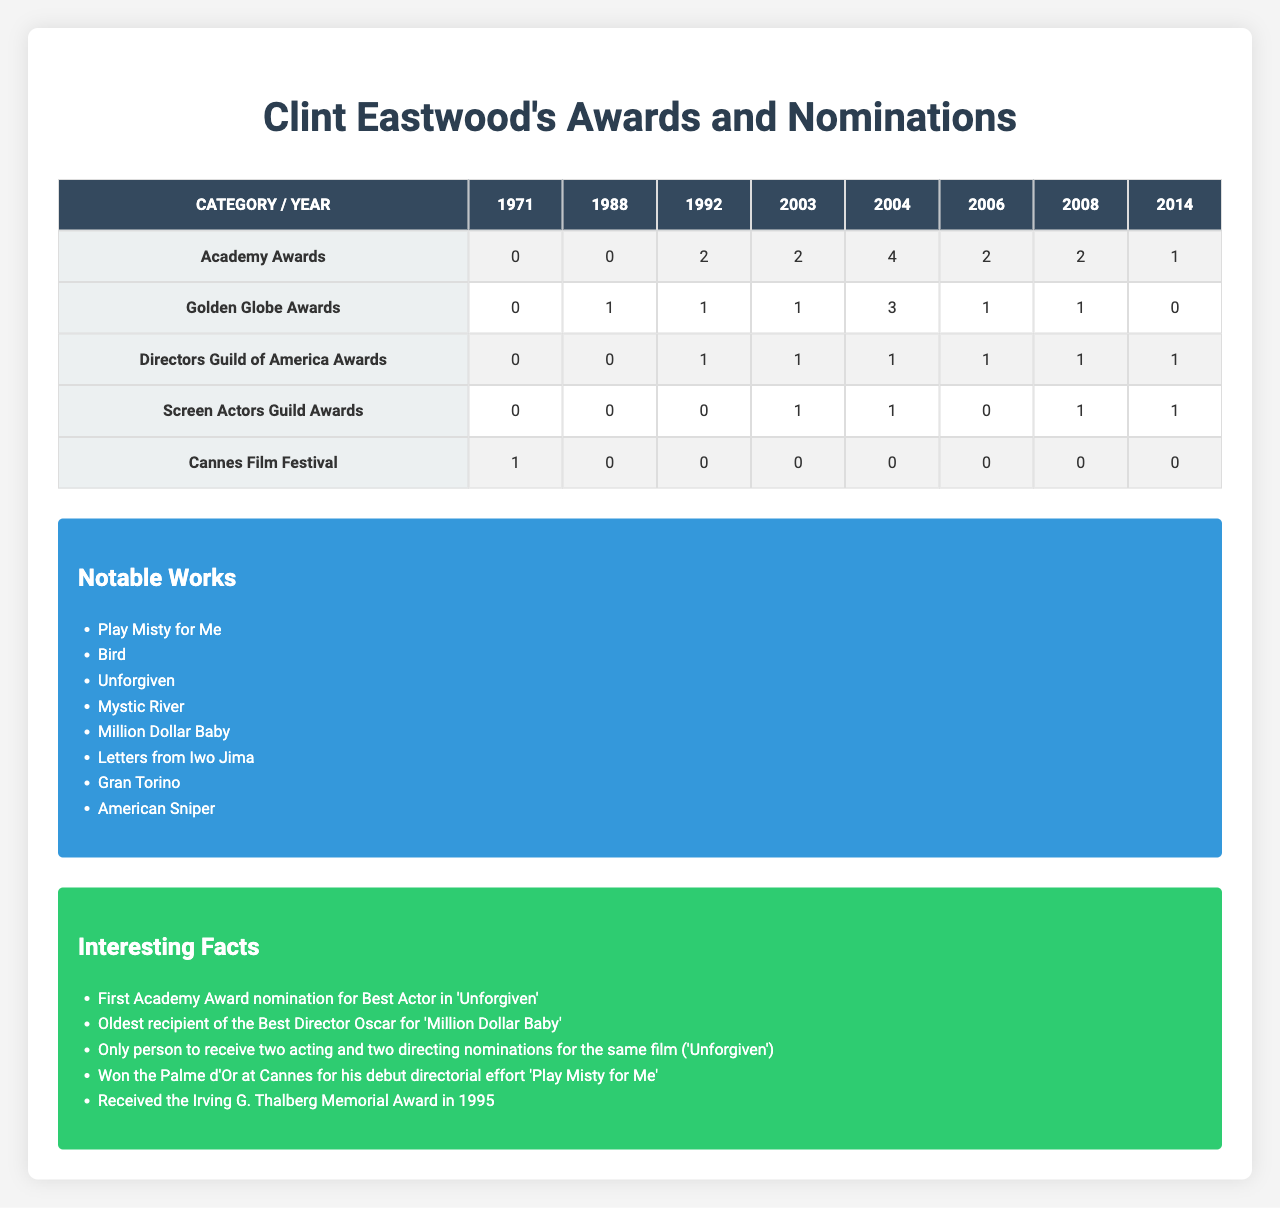What is the total number of Academy Awards won by Clint Eastwood? According to the table, Clint Eastwood won 2 Academy Awards in 2003 and 4 in 2004. The total number is 2 + 4 = 6.
Answer: 6 In which year did Clint Eastwood receive the highest number of Golden Globe Awards? Referring to the table, Clint Eastwood received 3 Golden Globe Awards in 2004, which is the highest number compared to other years.
Answer: 2004 How many awards did Clint Eastwood receive at the Cannes Film Festival? The table shows that Clint Eastwood received 0 awards at the Cannes Film Festival across all years listed.
Answer: 0 Did Clint Eastwood win any Screen Actors Guild Awards in 2006? Looking at the table, Clint Eastwood received 0 Screen Actors Guild Awards in 2006 as indicated in that row.
Answer: No What was the difference between the number of Directors Guild of America Awards received in 2004 and 2006? The table indicates that Clint Eastwood received 1 Directors Guild of America Award in 2004 and 1 in 2006. The difference is 1 - 1 = 0.
Answer: 0 In which year did Clint Eastwood receive a nomination for the highest number of awards across all categories? By checking the table, it can be seen that the year 2004 had the highest number of nominations: 4 Academy Awards, 3 Golden Globe Awards, 1 Directors Guild of America Award, and 1 Screen Actors Guild Award, totaling 9 nominations.
Answer: 2004 What are the notable works associated with Clint Eastwood? The table lists several notable works by Clint Eastwood, including "Play Misty for Me," "Bird," "Unforgiven," "Mystic River," "Million Dollar Baby," "Letters from Iwo Jima," "Gran Torino," and "American Sniper."
Answer: The notable works listed How many Golden Globe nominations did Clint Eastwood receive in 1992 compared to 2008? In 1992, Clint Eastwood received 1 Golden Globe nomination, and in 2008 he received 0. Thus, the comparison is 1 - 0 = 1 more nomination in 1992.
Answer: 1 Which award category did Clint Eastwood have the most nominations in total over all the years? Summing up the awards across all years, the maximum shows 6 nominations in the Academy Awards category (2 in 2003 and 4 in 2004).
Answer: Academy Awards Was Clint Eastwood the oldest recipient of any Oscar, and if so, for which film? Yes, the table mentions he was the oldest recipient of the Best Director Oscar for "Million Dollar Baby."
Answer: Yes, for "Million Dollar Baby." 